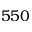Convert formula to latex. <formula><loc_0><loc_0><loc_500><loc_500>5 5 0</formula> 